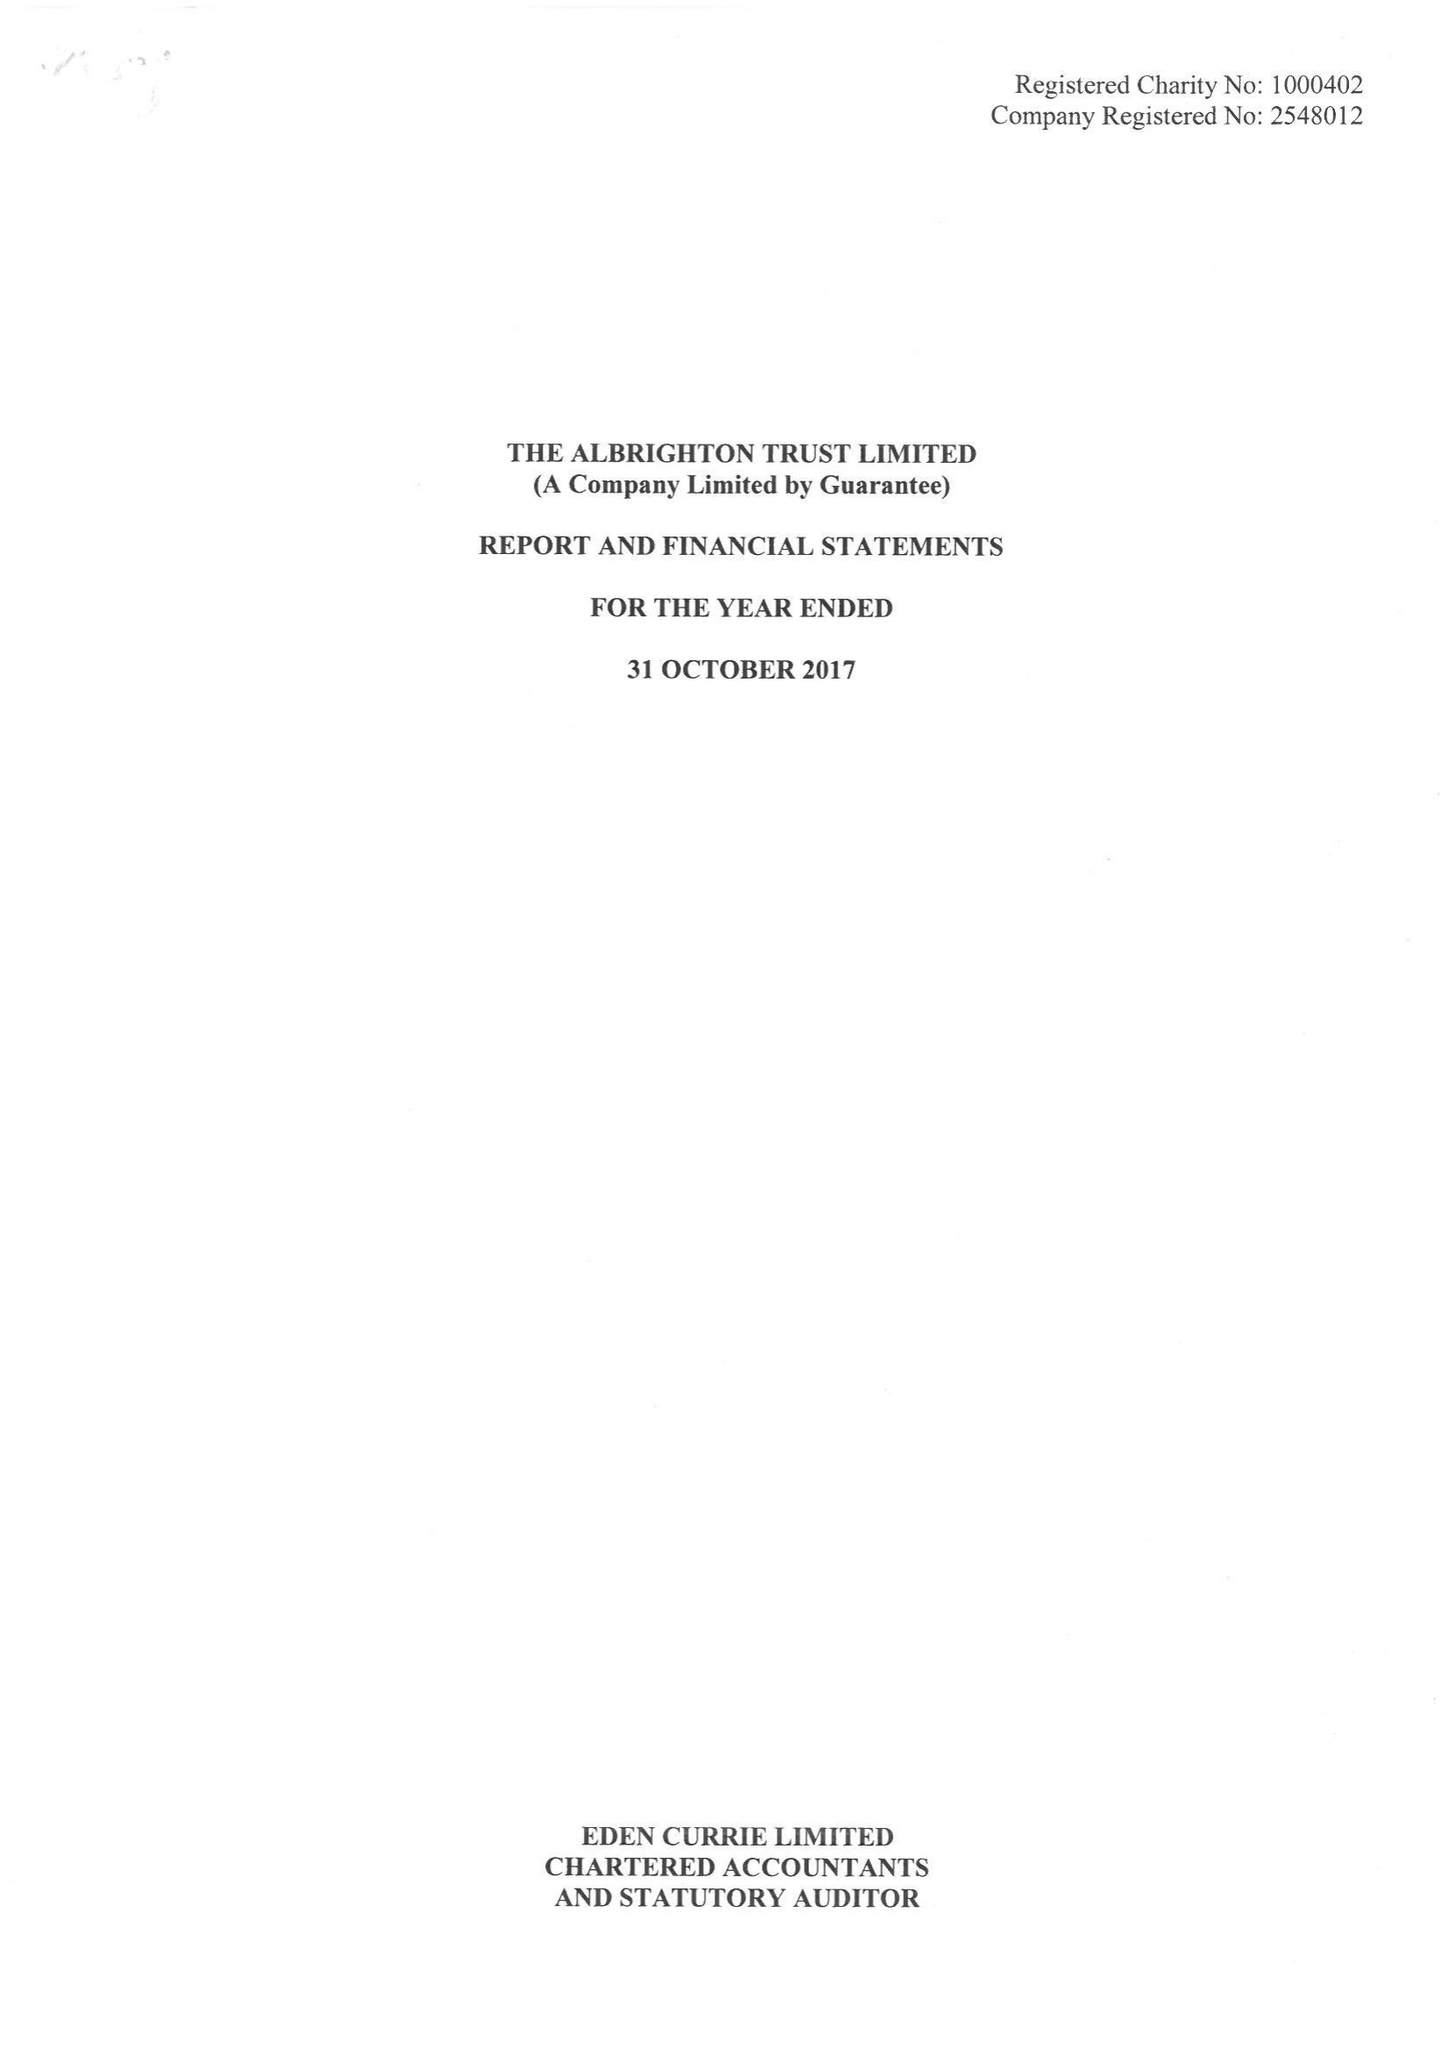What is the value for the address__street_line?
Answer the question using a single word or phrase. BLUE HOUSE LANE 